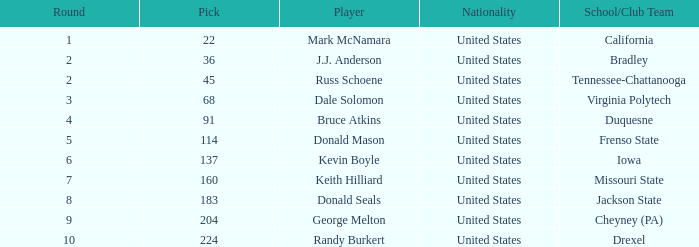What is the nationality of the player from Drexel who had a pick larger than 183? United States. 